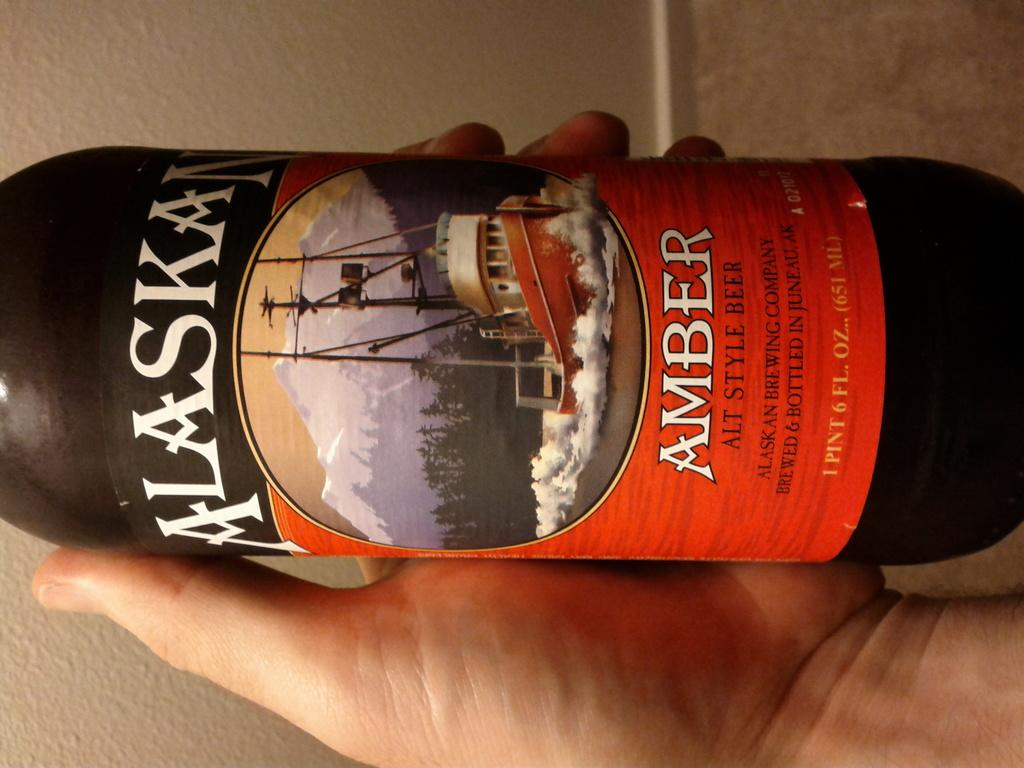<image>
Summarize the visual content of the image. Brown bottle with Alaskan Amber in white letters and a ship on the label. 